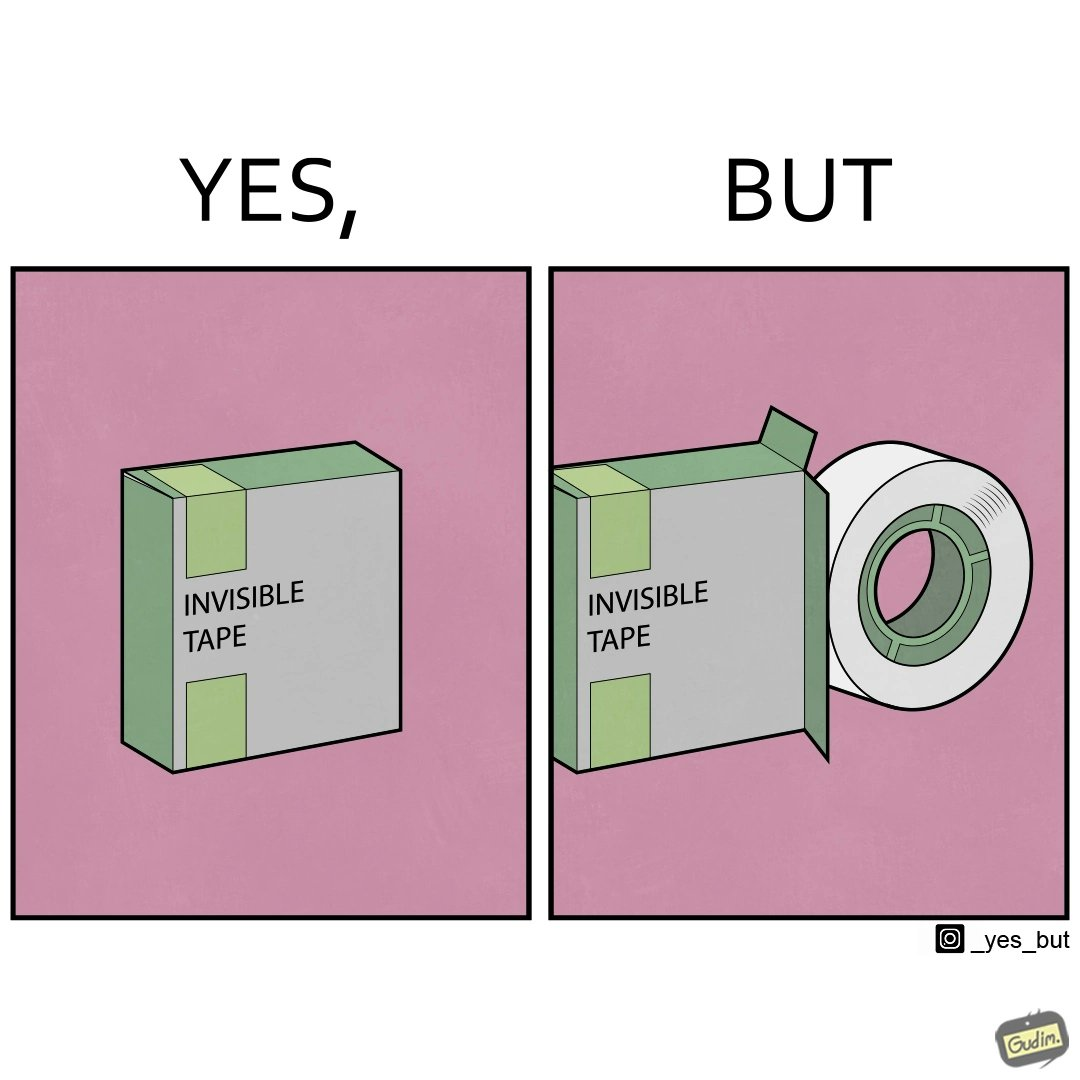Provide a description of this image. The image is ironic, as the text on the pack reads 'invisible tape', but the tape inside it is actually visible. 